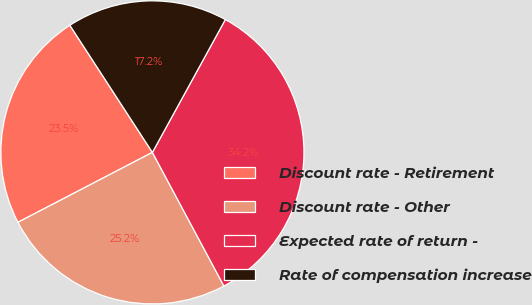<chart> <loc_0><loc_0><loc_500><loc_500><pie_chart><fcel>Discount rate - Retirement<fcel>Discount rate - Other<fcel>Expected rate of return -<fcel>Rate of compensation increase<nl><fcel>23.47%<fcel>25.19%<fcel>34.19%<fcel>17.16%<nl></chart> 